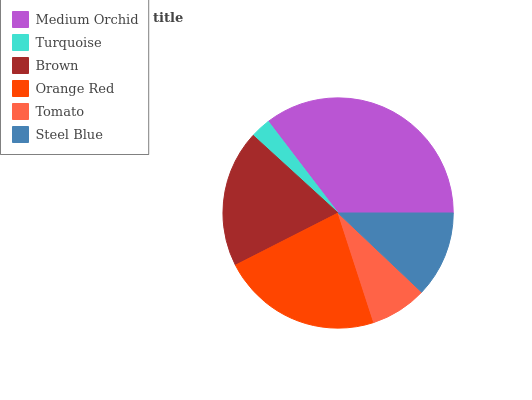Is Turquoise the minimum?
Answer yes or no. Yes. Is Medium Orchid the maximum?
Answer yes or no. Yes. Is Brown the minimum?
Answer yes or no. No. Is Brown the maximum?
Answer yes or no. No. Is Brown greater than Turquoise?
Answer yes or no. Yes. Is Turquoise less than Brown?
Answer yes or no. Yes. Is Turquoise greater than Brown?
Answer yes or no. No. Is Brown less than Turquoise?
Answer yes or no. No. Is Brown the high median?
Answer yes or no. Yes. Is Steel Blue the low median?
Answer yes or no. Yes. Is Medium Orchid the high median?
Answer yes or no. No. Is Orange Red the low median?
Answer yes or no. No. 